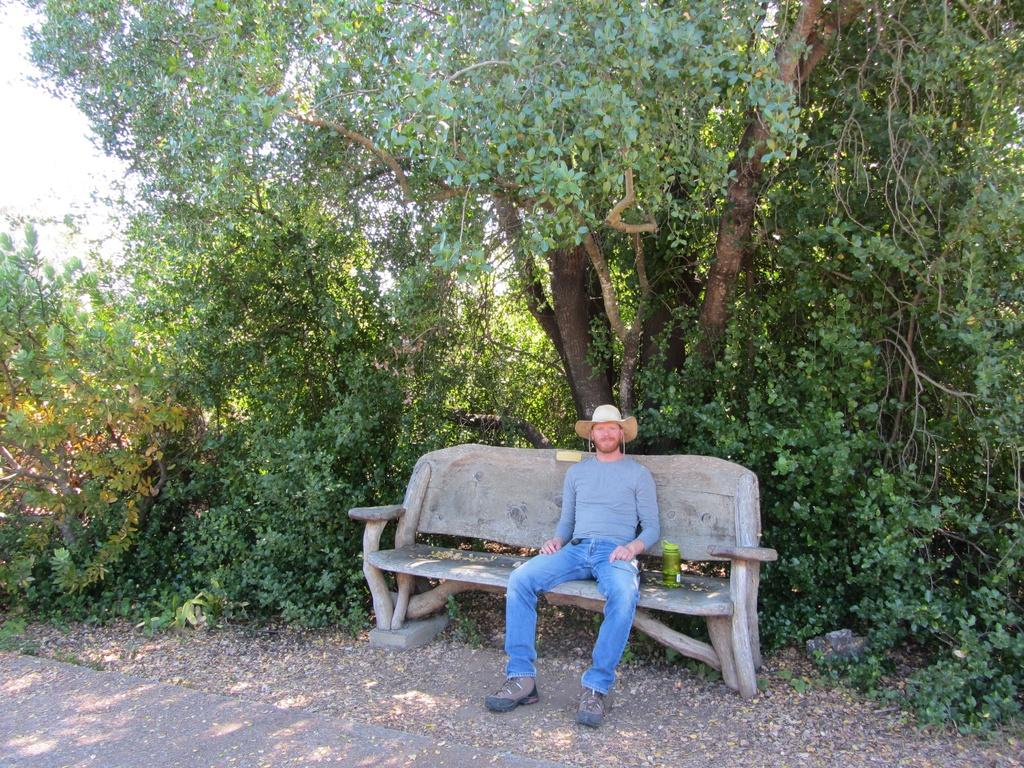What is the man in the image doing? The man is sitting on a stone chair in the image. What is the man's facial expression? The man is smiling. What can be seen in the background of the image? There are trees in the background of the image. What does the man regret doing in the image? There is no indication in the image that the man regrets doing anything, as he is smiling. What does the man believe in, as depicted in the image? There is no information in the image about the man's beliefs. 